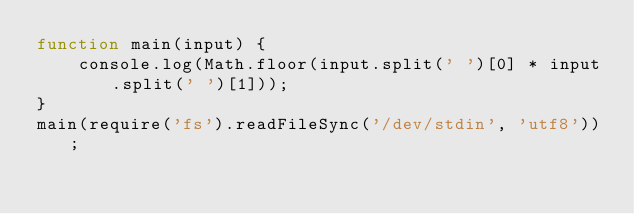<code> <loc_0><loc_0><loc_500><loc_500><_JavaScript_>function main(input) {
    console.log(Math.floor(input.split(' ')[0] * input.split(' ')[1]));
}
main(require('fs').readFileSync('/dev/stdin', 'utf8'));</code> 